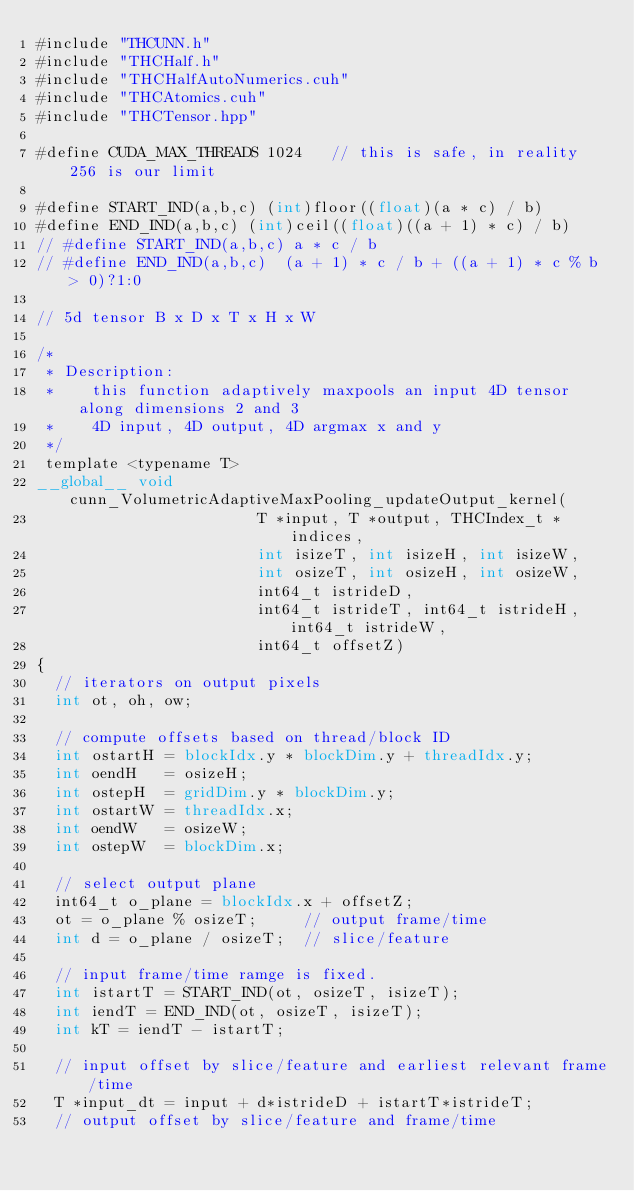Convert code to text. <code><loc_0><loc_0><loc_500><loc_500><_Cuda_>#include "THCUNN.h"
#include "THCHalf.h"
#include "THCHalfAutoNumerics.cuh"
#include "THCAtomics.cuh"
#include "THCTensor.hpp"

#define CUDA_MAX_THREADS 1024   // this is safe, in reality 256 is our limit

#define START_IND(a,b,c) (int)floor((float)(a * c) / b)
#define END_IND(a,b,c) (int)ceil((float)((a + 1) * c) / b)
// #define START_IND(a,b,c) a * c / b
// #define END_IND(a,b,c)  (a + 1) * c / b + ((a + 1) * c % b > 0)?1:0

// 5d tensor B x D x T x H x W

/*
 * Description:
 *    this function adaptively maxpools an input 4D tensor along dimensions 2 and 3
 *    4D input, 4D output, 4D argmax x and y
 */
 template <typename T>
__global__ void cunn_VolumetricAdaptiveMaxPooling_updateOutput_kernel(
                        T *input, T *output, THCIndex_t *indices,
                        int isizeT, int isizeH, int isizeW,
                        int osizeT, int osizeH, int osizeW,
                        int64_t istrideD,
                        int64_t istrideT, int64_t istrideH, int64_t istrideW,
                        int64_t offsetZ)
{
  // iterators on output pixels
  int ot, oh, ow;

  // compute offsets based on thread/block ID
  int ostartH = blockIdx.y * blockDim.y + threadIdx.y;
  int oendH   = osizeH;
  int ostepH  = gridDim.y * blockDim.y;
  int ostartW = threadIdx.x;
  int oendW   = osizeW;
  int ostepW  = blockDim.x;

  // select output plane
  int64_t o_plane = blockIdx.x + offsetZ;
  ot = o_plane % osizeT;     // output frame/time
  int d = o_plane / osizeT;  // slice/feature

  // input frame/time ramge is fixed.
  int istartT = START_IND(ot, osizeT, isizeT);
  int iendT = END_IND(ot, osizeT, isizeT);
  int kT = iendT - istartT;

  // input offset by slice/feature and earliest relevant frame/time
  T *input_dt = input + d*istrideD + istartT*istrideT;
  // output offset by slice/feature and frame/time</code> 